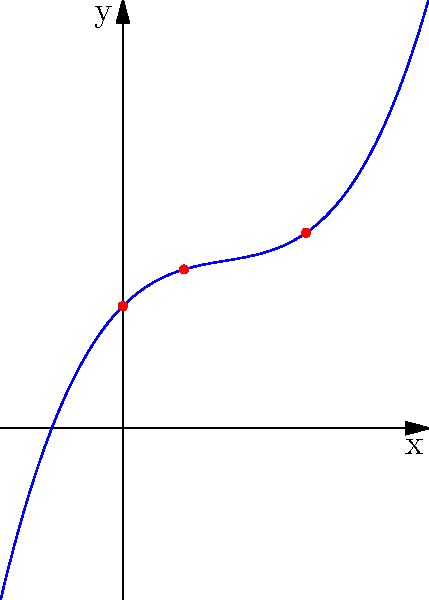A spiral pattern in a metalwork chandelier can be modeled by the polynomial function $f(x) = 0.1x^3 - 0.5x^2 + x + 2$, where $x$ represents the angle of rotation (in radians) and $f(x)$ represents the radius of the spiral (in centimeters) at that angle. Analyze the function and determine the number of real roots in the interval $[0, 3]$. To determine the number of real roots in the interval $[0, 3]$, we need to follow these steps:

1) First, let's evaluate the function at the endpoints of the interval:
   At $x = 0$: $f(0) = 2$
   At $x = 3$: $f(3) = 0.1(27) - 0.5(9) + 3 + 2 = 2.7 - 4.5 + 5 = 3.2$

2) We can see that $f(0) = 2$ and $f(3) = 3.2$, both positive. If there are any roots in this interval, there must be an even number of them (0 or 2) due to the intermediate value theorem.

3) To check for roots within the interval, let's find the derivative of $f(x)$:
   $f'(x) = 0.3x^2 - x + 1$

4) Setting $f'(x) = 0$ to find critical points:
   $0.3x^2 - x + 1 = 0$
   This is a quadratic equation. Using the quadratic formula, we get:
   $x = \frac{1 \pm \sqrt{1^2 - 4(0.3)(1)}}{2(0.3)} = \frac{1 \pm \sqrt{-0.2}}{0.6}$

5) Since $\sqrt{-0.2}$ is not a real number, there are no real critical points.

6) This means the function is strictly increasing on the interval $[0, 3]$, as we can see from the graph.

7) Therefore, there are no roots in the interval $[0, 3]$.
Answer: 0 roots 